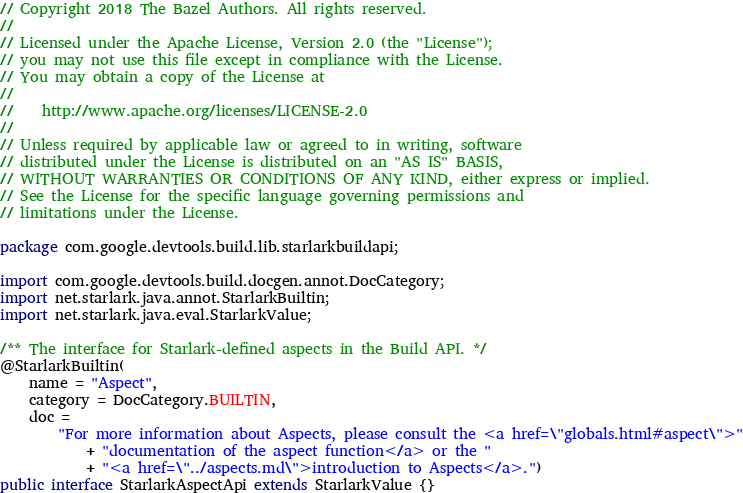<code> <loc_0><loc_0><loc_500><loc_500><_Java_>// Copyright 2018 The Bazel Authors. All rights reserved.
//
// Licensed under the Apache License, Version 2.0 (the "License");
// you may not use this file except in compliance with the License.
// You may obtain a copy of the License at
//
//    http://www.apache.org/licenses/LICENSE-2.0
//
// Unless required by applicable law or agreed to in writing, software
// distributed under the License is distributed on an "AS IS" BASIS,
// WITHOUT WARRANTIES OR CONDITIONS OF ANY KIND, either express or implied.
// See the License for the specific language governing permissions and
// limitations under the License.

package com.google.devtools.build.lib.starlarkbuildapi;

import com.google.devtools.build.docgen.annot.DocCategory;
import net.starlark.java.annot.StarlarkBuiltin;
import net.starlark.java.eval.StarlarkValue;

/** The interface for Starlark-defined aspects in the Build API. */
@StarlarkBuiltin(
    name = "Aspect",
    category = DocCategory.BUILTIN,
    doc =
        "For more information about Aspects, please consult the <a href=\"globals.html#aspect\">"
            + "documentation of the aspect function</a> or the "
            + "<a href=\"../aspects.md\">introduction to Aspects</a>.")
public interface StarlarkAspectApi extends StarlarkValue {}
</code> 